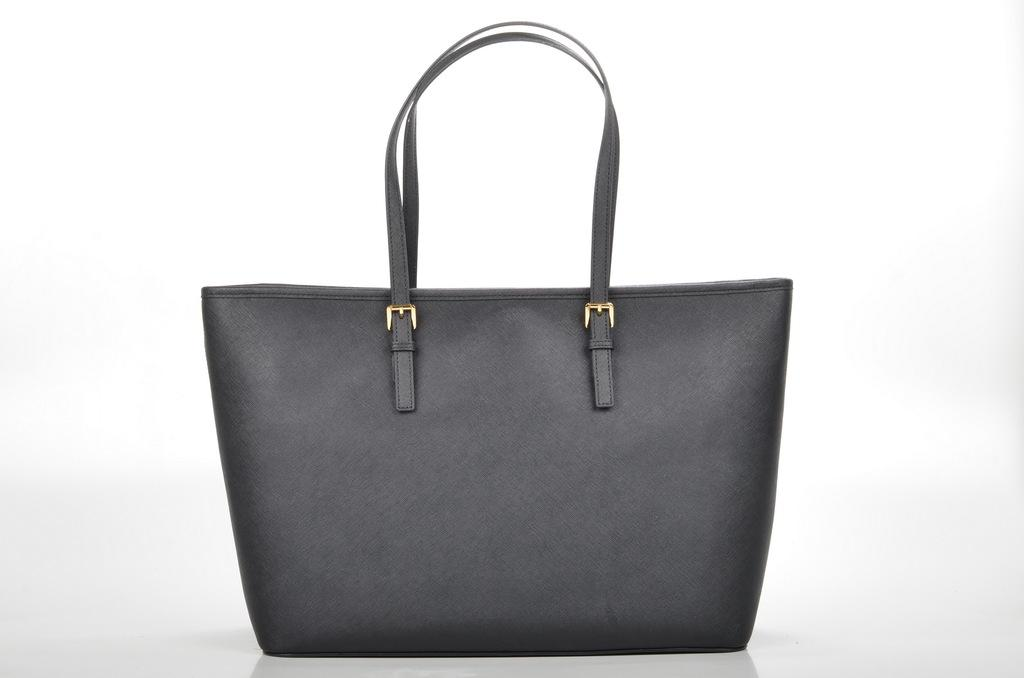What type of accessory is in the image? There is a grey handbag in the image. What feature can be seen on the handbag's handles? The handbag has buckles on its handles. What color is the background of the image? The background of the image is white. Can you see any signs of harmony or destruction in the image? The image does not depict any signs of harmony or destruction; it features a grey handbag with buckles on its handles against a white background. 